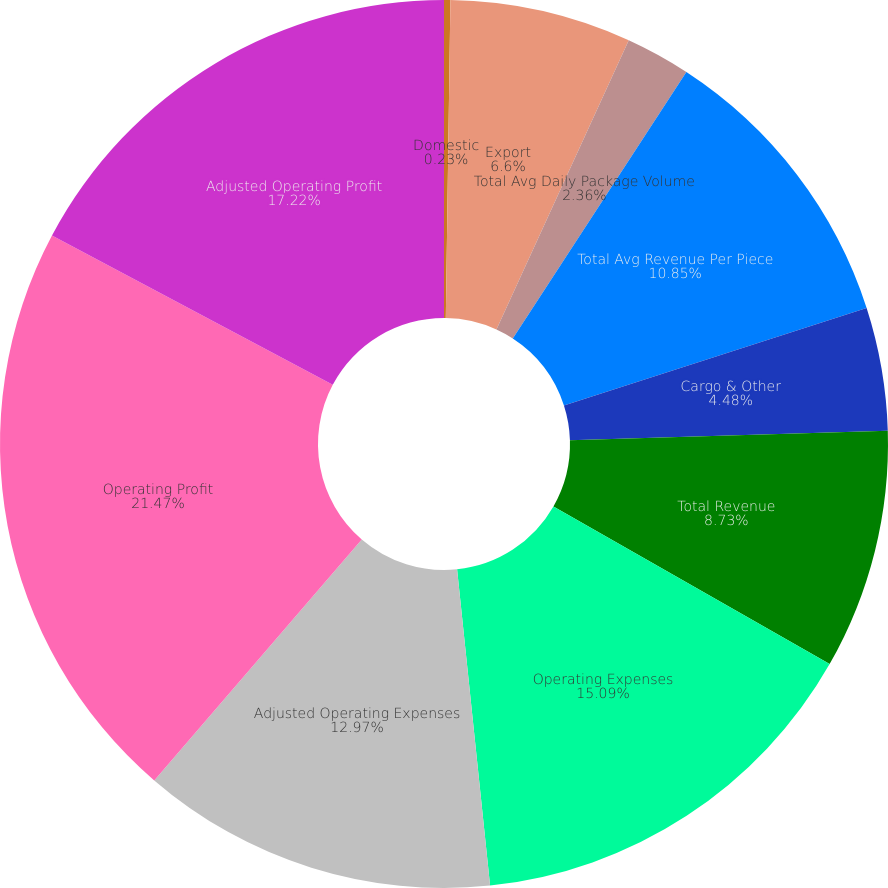Convert chart. <chart><loc_0><loc_0><loc_500><loc_500><pie_chart><fcel>Domestic<fcel>Export<fcel>Total Avg Daily Package Volume<fcel>Total Avg Revenue Per Piece<fcel>Cargo & Other<fcel>Total Revenue<fcel>Operating Expenses<fcel>Adjusted Operating Expenses<fcel>Operating Profit<fcel>Adjusted Operating Profit<nl><fcel>0.23%<fcel>6.6%<fcel>2.36%<fcel>10.85%<fcel>4.48%<fcel>8.73%<fcel>15.09%<fcel>12.97%<fcel>21.46%<fcel>17.22%<nl></chart> 